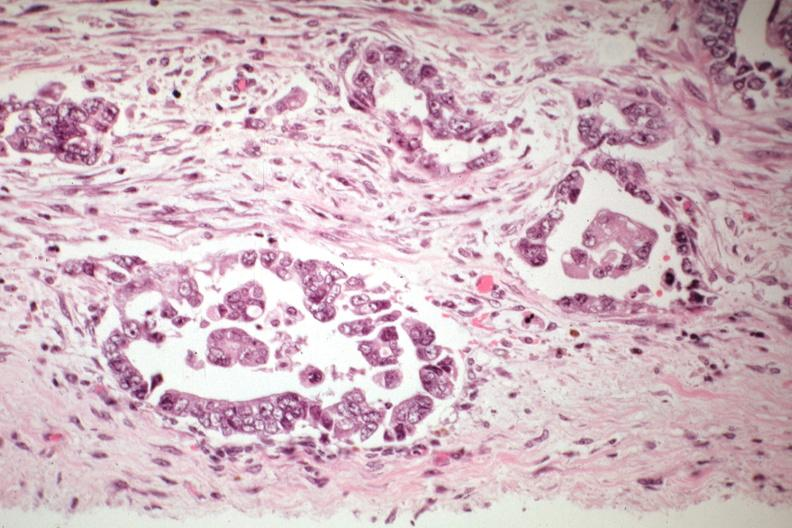does this image show adenocarcinoma in pelvic peritoneum?
Answer the question using a single word or phrase. Yes 